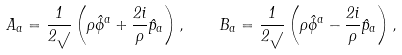<formula> <loc_0><loc_0><loc_500><loc_500>A _ { a } = \frac { 1 } { 2 \sqrt { } } \left ( \rho \hat { \phi } ^ { a } + \frac { 2 i } { \rho } \hat { p } _ { a } \right ) , \quad B _ { a } = \frac { 1 } { 2 \sqrt { } } \left ( \rho \hat { \phi } ^ { a } - \frac { 2 i } { \rho } \hat { p } _ { a } \right ) ,</formula> 